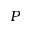<formula> <loc_0><loc_0><loc_500><loc_500>P</formula> 